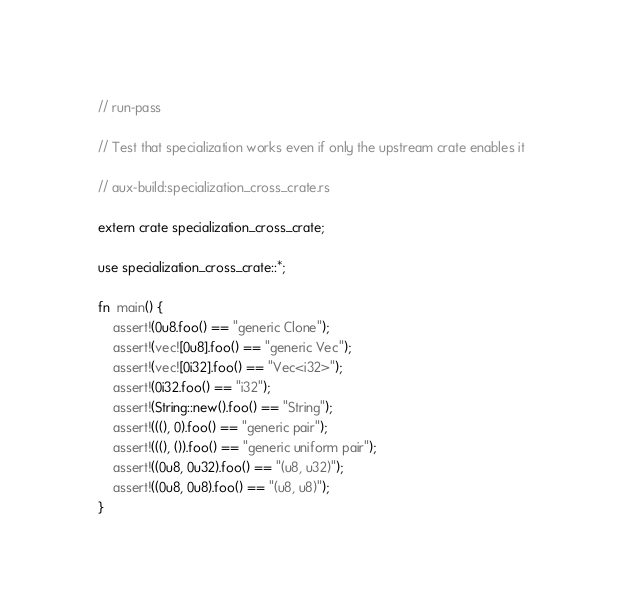<code> <loc_0><loc_0><loc_500><loc_500><_Rust_>// run-pass

// Test that specialization works even if only the upstream crate enables it

// aux-build:specialization_cross_crate.rs

extern crate specialization_cross_crate;

use specialization_cross_crate::*;

fn  main() {
    assert!(0u8.foo() == "generic Clone");
    assert!(vec![0u8].foo() == "generic Vec");
    assert!(vec![0i32].foo() == "Vec<i32>");
    assert!(0i32.foo() == "i32");
    assert!(String::new().foo() == "String");
    assert!(((), 0).foo() == "generic pair");
    assert!(((), ()).foo() == "generic uniform pair");
    assert!((0u8, 0u32).foo() == "(u8, u32)");
    assert!((0u8, 0u8).foo() == "(u8, u8)");
}
</code> 